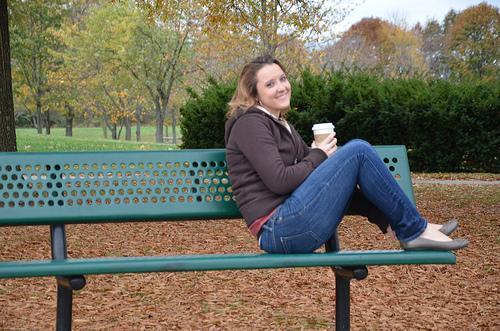How many people are in the photo?
Give a very brief answer. 1. 